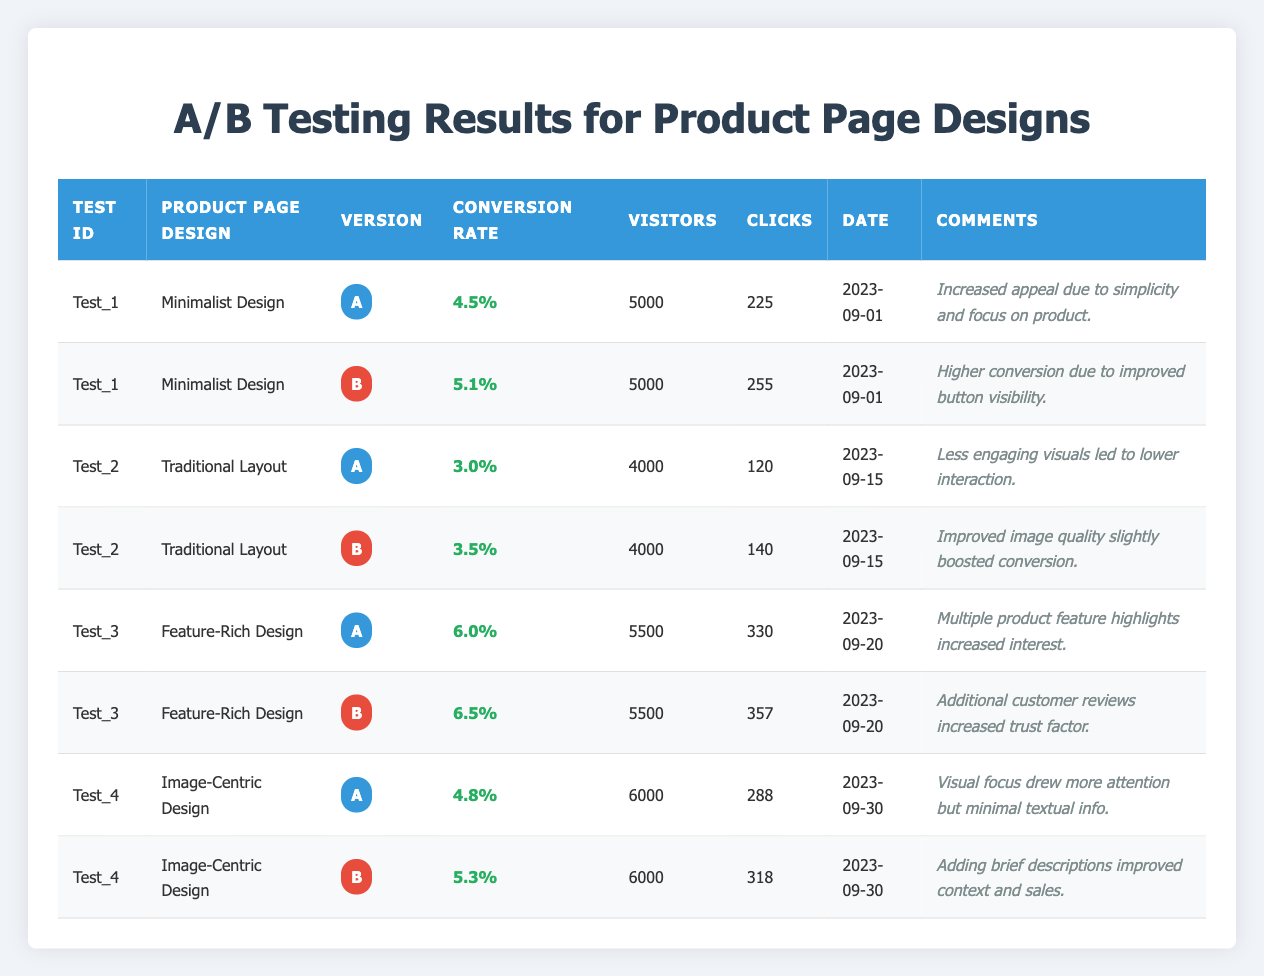What is the highest conversion rate recorded in the table? By reviewing the "Conversion Rate" column, we can see the rates listed for each version. The highest rate appears in Test_3, Version B, with a conversion rate of 6.5%.
Answer: 6.5% How many visitors were recorded for Test_4, Version A? The table shows that Test_4, Version A had 6000 visitors, as indicated in the "Visitors" column corresponding to that row.
Answer: 6000 What is the difference in conversion rates between Version B of Test_1 and Test_2? For Test_1, Version B has a conversion rate of 5.1%, and for Test_2, Version B has a conversion rate of 3.5%. The difference is 5.1% - 3.5% = 1.6%.
Answer: 1.6% Did the "Feature-Rich Design" in Version A have more clicks than "Image-Centric Design" in Version B? The "Feature-Rich Design" in Version A had 330 clicks, whereas "Image-Centric Design" in Version B had 318 clicks. Since 330 is greater than 318, the statement is true.
Answer: Yes What is the average conversion rate for all Version A tests? The conversion rates for Version A are 4.5%, 3.0%, 6.0%, and 4.8%. To find the average, we sum these values: 4.5 + 3.0 + 6.0 + 4.8 = 18.3%. There are 4 tests, so the average is 18.3% / 4 = 4.575%.
Answer: 4.575% Which design version received the highest number of clicks? By comparing the "Clicks" column across all tests, Version B of Test_3 recorded the highest number of clicks with 357 clicks.
Answer: 357 Was the conversion rate for Traditional Layout Version A higher than that for Image-Centric Design Version A? Traditional Layout Version A had a conversion rate of 3.0%, while Image-Centric Design Version A had a conversion rate of 4.8%. Since 3.0% is less than 4.8%, the statement is false.
Answer: No What was the total number of visitors across all tests in the dataset? The total number of visitors can be calculated by adding all visitors from each test: 5000 + 5000 + 4000 + 4000 + 5500 + 5500 + 6000 + 6000 = 41500.
Answer: 41500 What percentage increase in conversion rate did Test_4 have from Version A to Version B? The conversion rate for Version A of Test_4 was 4.8% and for Version B it was 5.3%. The increase is 5.3% - 4.8% = 0.5%. To find the percentage increase, divide the increase by the original rate: (0.5% / 4.8%) * 100 = 10.42%.
Answer: 10.42% 